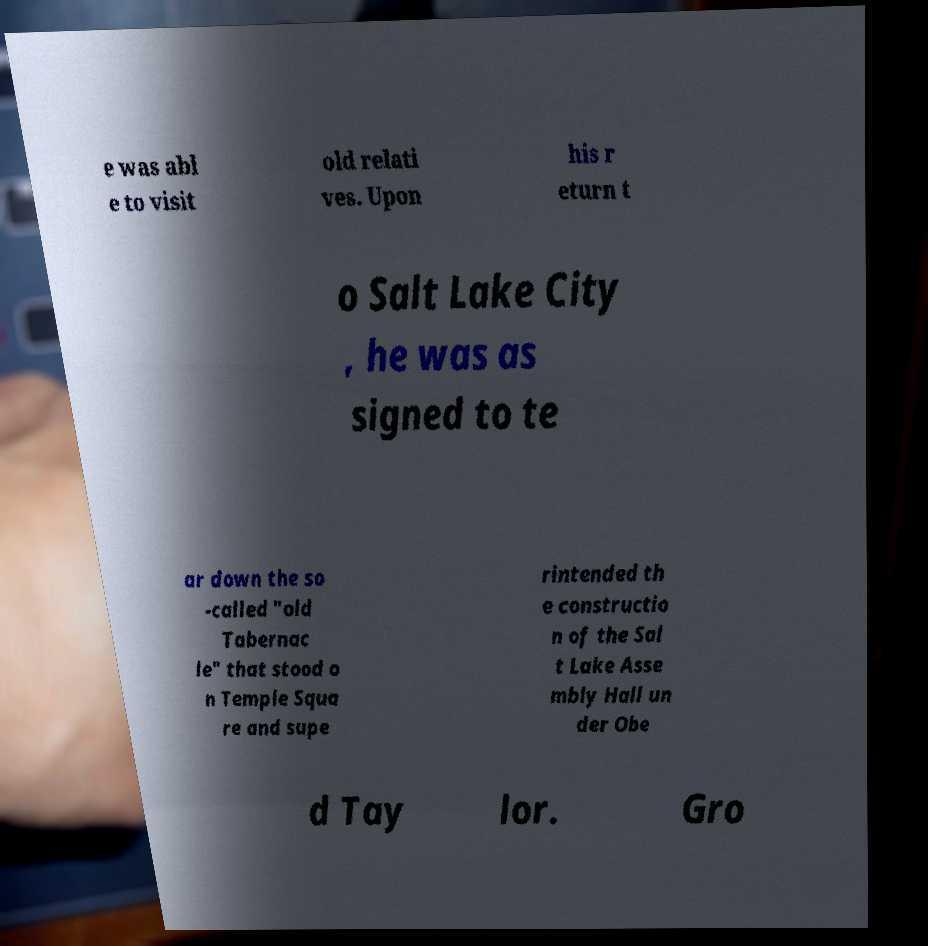What messages or text are displayed in this image? I need them in a readable, typed format. e was abl e to visit old relati ves. Upon his r eturn t o Salt Lake City , he was as signed to te ar down the so -called "old Tabernac le" that stood o n Temple Squa re and supe rintended th e constructio n of the Sal t Lake Asse mbly Hall un der Obe d Tay lor. Gro 